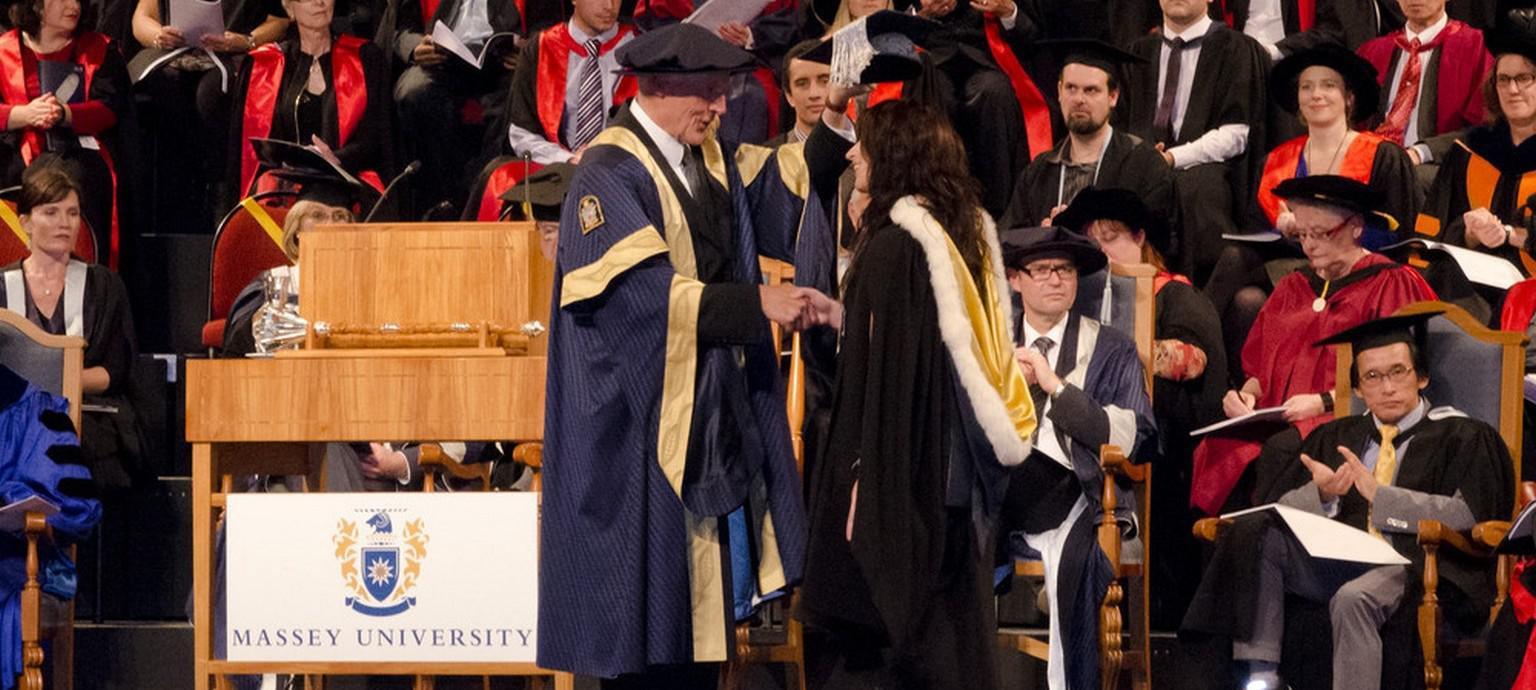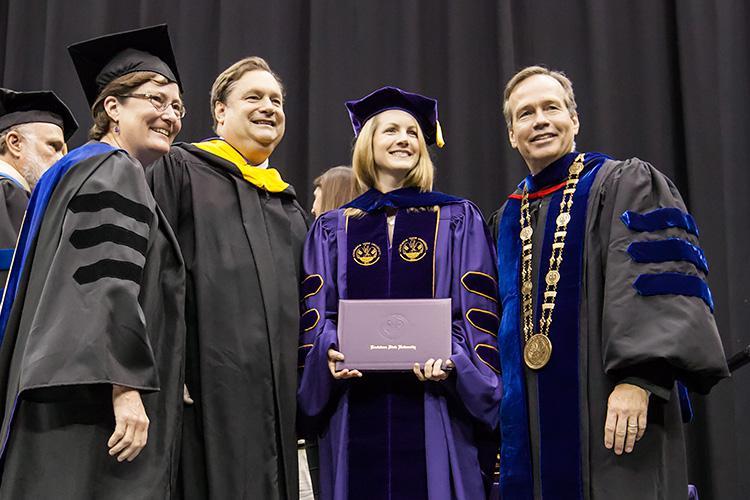The first image is the image on the left, the second image is the image on the right. Assess this claim about the two images: "The graduates in each picture are posing outside.". Correct or not? Answer yes or no. No. The first image is the image on the left, the second image is the image on the right. Assess this claim about the two images: "One image shows a group of graduates posed outdoors wearing different colored robes with three black stripes per sleeve.". Correct or not? Answer yes or no. No. 